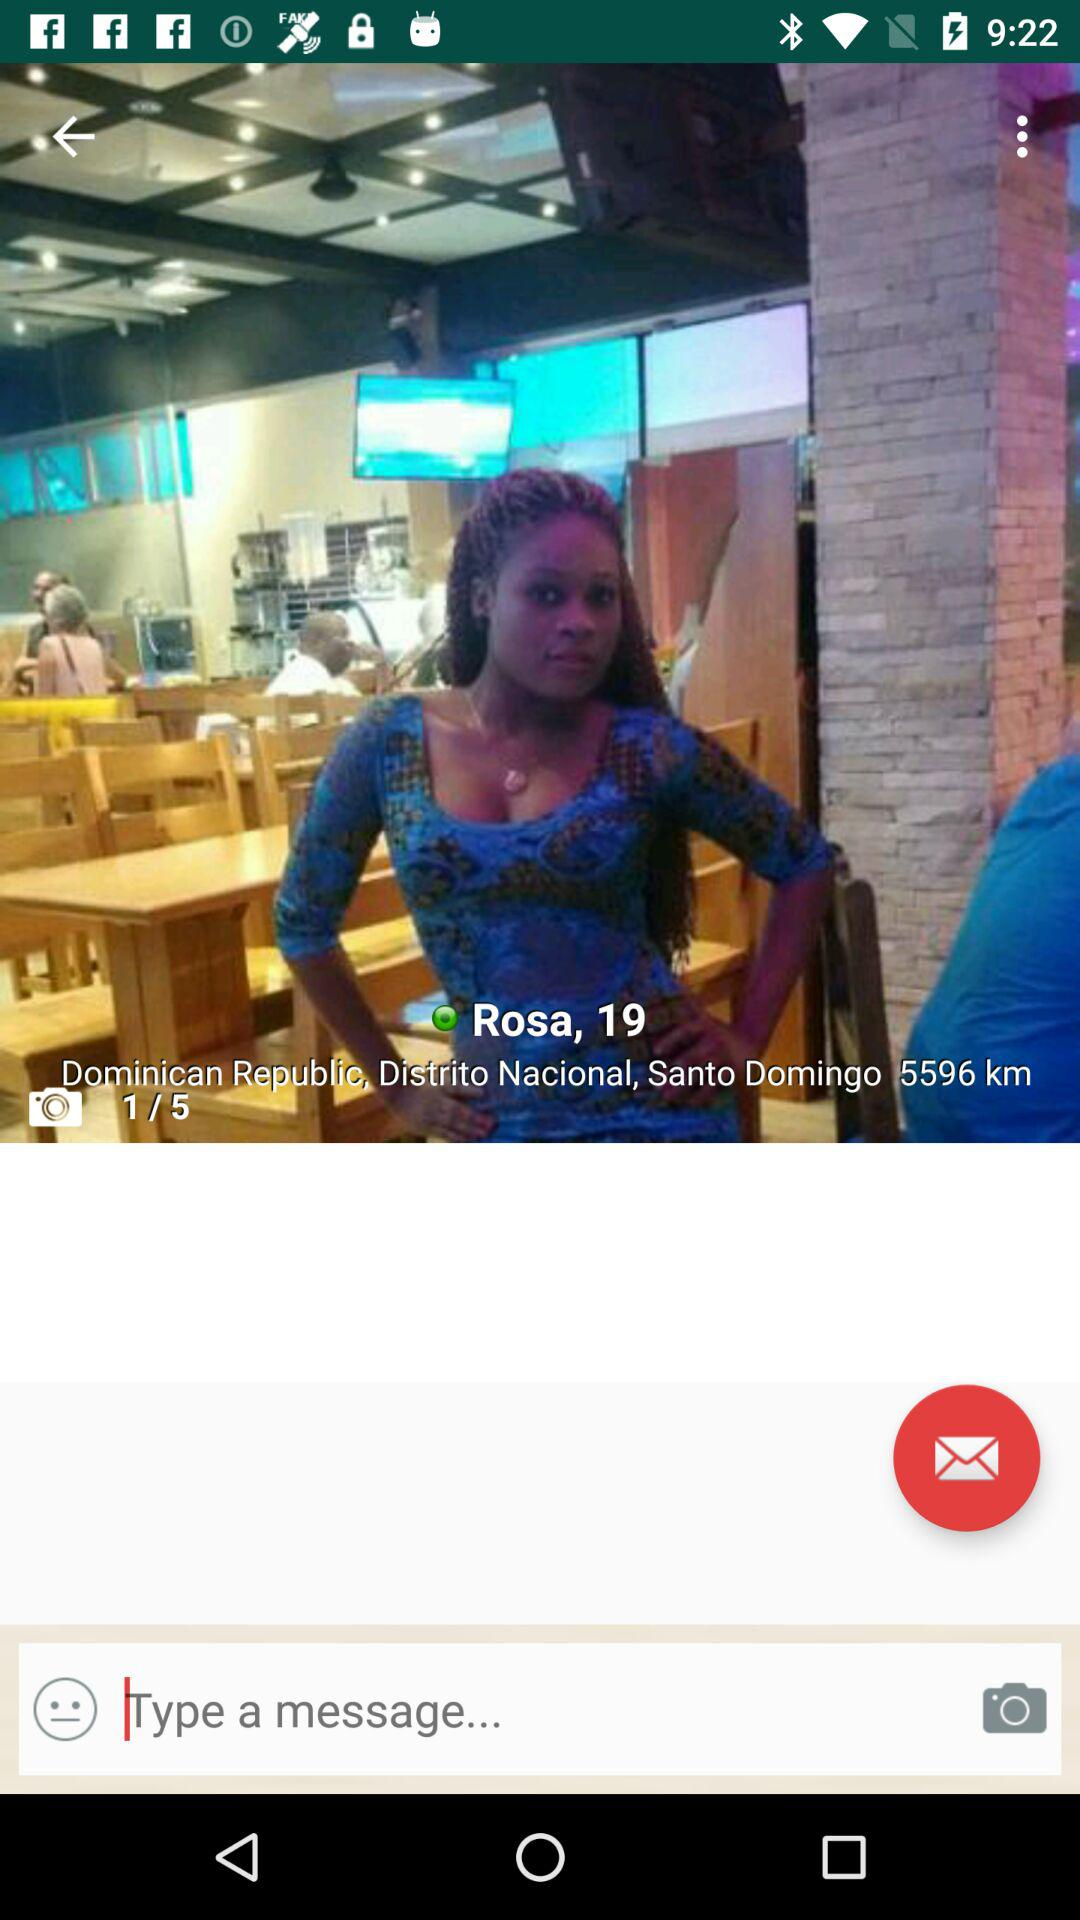Out of the total photos,which photo are we looking at? Out of the total photos, you are looking at photo 1. 